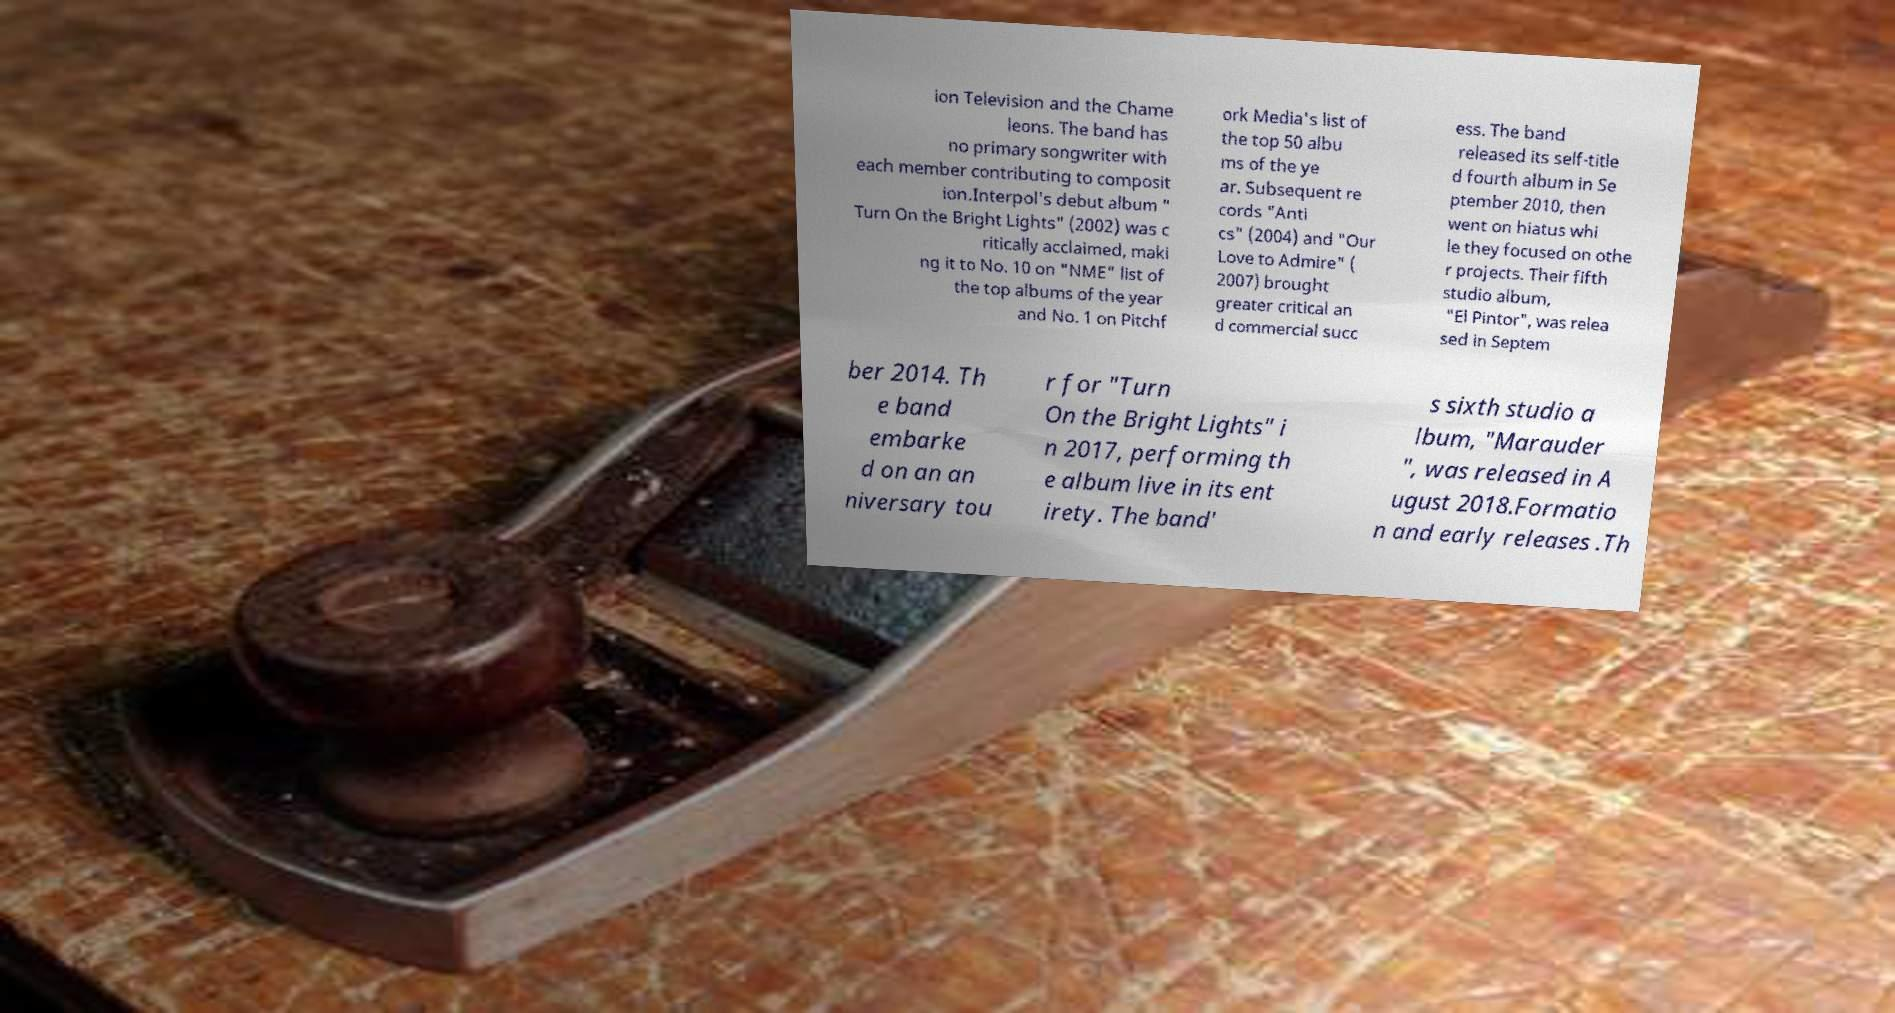Please identify and transcribe the text found in this image. ion Television and the Chame leons. The band has no primary songwriter with each member contributing to composit ion.Interpol's debut album " Turn On the Bright Lights" (2002) was c ritically acclaimed, maki ng it to No. 10 on "NME" list of the top albums of the year and No. 1 on Pitchf ork Media's list of the top 50 albu ms of the ye ar. Subsequent re cords "Anti cs" (2004) and "Our Love to Admire" ( 2007) brought greater critical an d commercial succ ess. The band released its self-title d fourth album in Se ptember 2010, then went on hiatus whi le they focused on othe r projects. Their fifth studio album, "El Pintor", was relea sed in Septem ber 2014. Th e band embarke d on an an niversary tou r for "Turn On the Bright Lights" i n 2017, performing th e album live in its ent irety. The band' s sixth studio a lbum, "Marauder ", was released in A ugust 2018.Formatio n and early releases .Th 